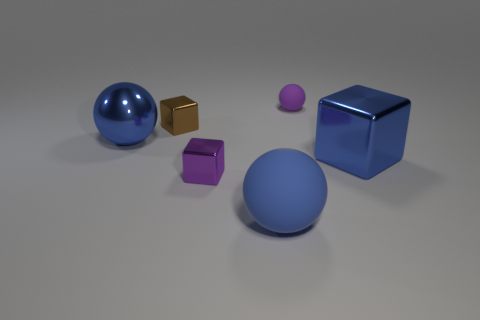How many large objects are either balls or metal balls?
Give a very brief answer. 2. What number of blue balls are made of the same material as the tiny brown cube?
Give a very brief answer. 1. What size is the blue object on the left side of the purple cube?
Your answer should be compact. Large. What shape is the tiny metal object that is left of the purple thing that is in front of the small purple rubber sphere?
Give a very brief answer. Cube. How many tiny brown metal things are to the right of the large shiny thing on the left side of the ball behind the tiny brown block?
Give a very brief answer. 1. Are there fewer big rubber things behind the big blue metal ball than large matte objects?
Make the answer very short. Yes. Is there any other thing that has the same shape as the brown metal thing?
Make the answer very short. Yes. There is a tiny thing behind the brown metallic thing; what shape is it?
Give a very brief answer. Sphere. There is a small purple thing on the left side of the matte object that is behind the big object right of the small purple ball; what shape is it?
Ensure brevity in your answer.  Cube. What number of objects are big matte objects or tiny brown blocks?
Offer a very short reply. 2. 